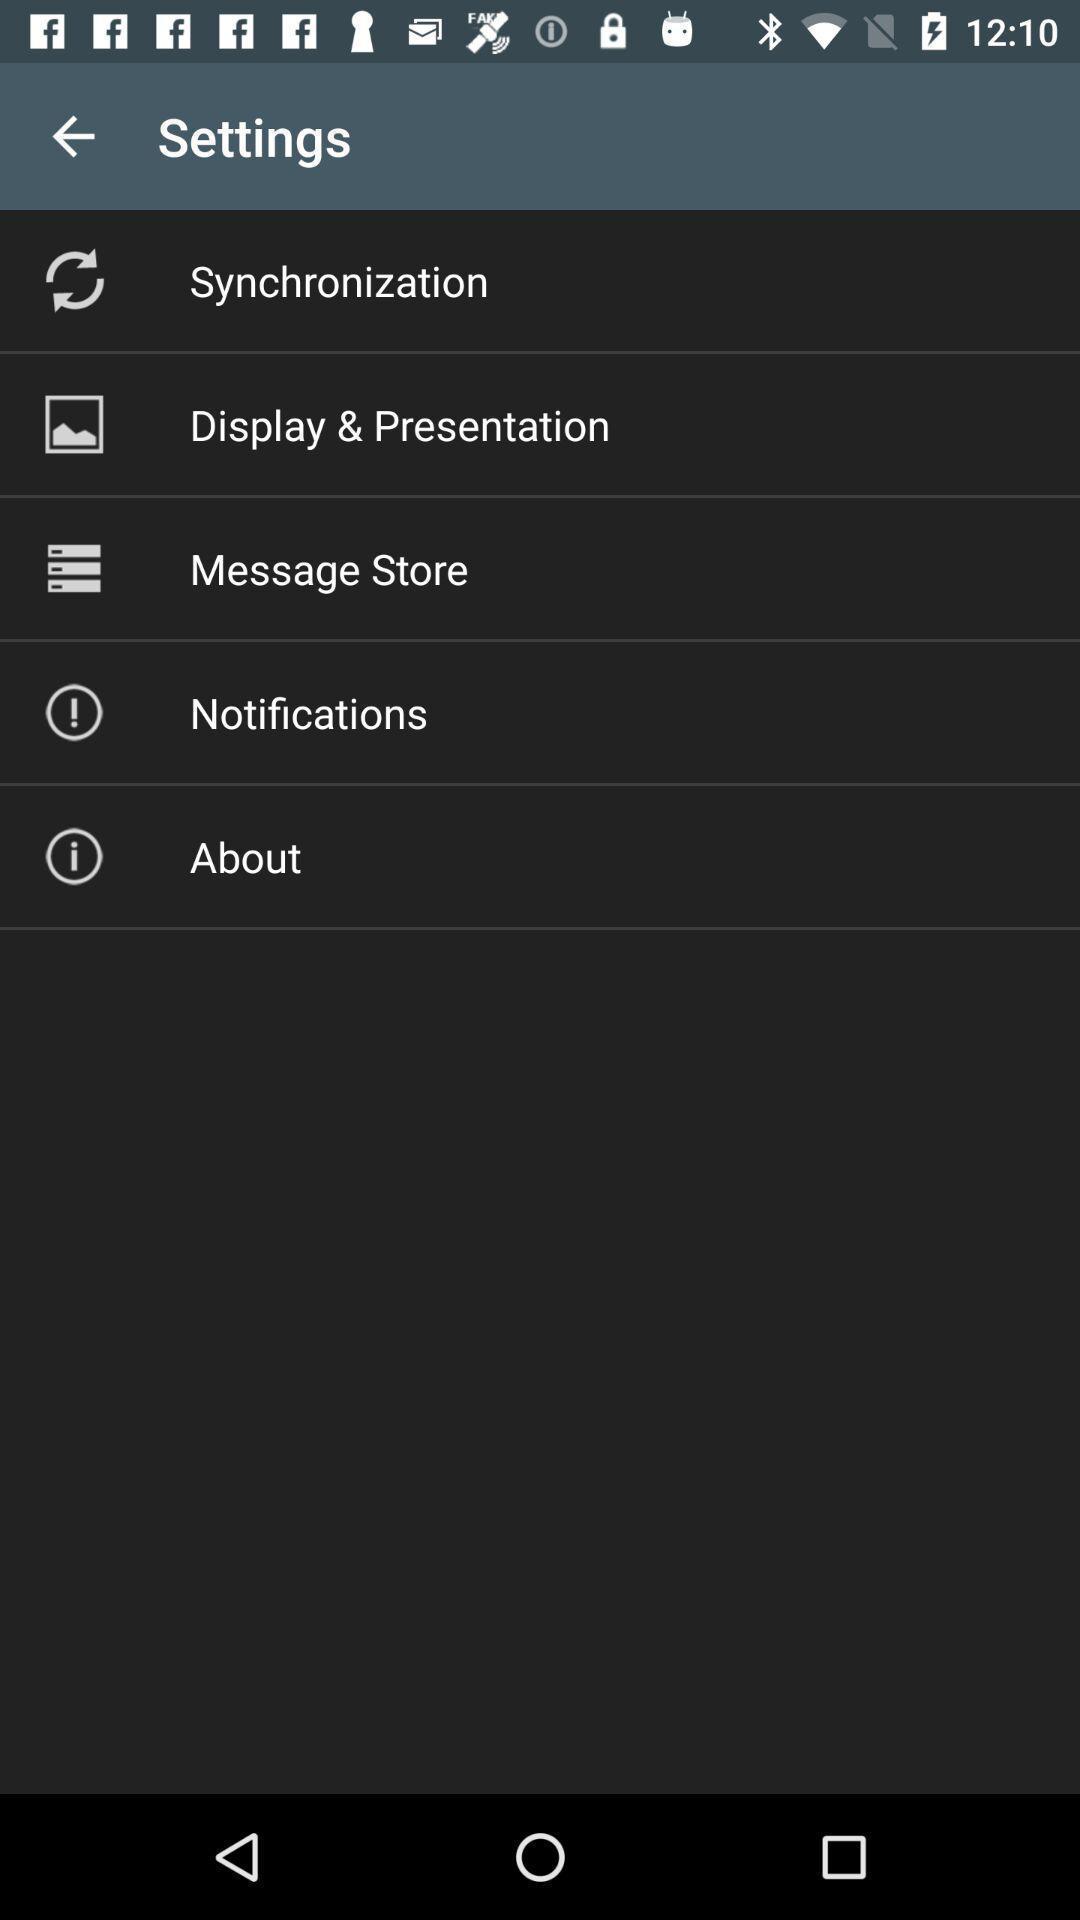Provide a detailed account of this screenshot. Screen displaying the settings page. 